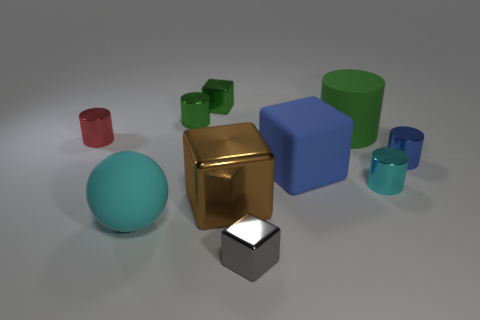Subtract all brown balls. How many green cylinders are left? 2 Subtract all gray metal cubes. How many cubes are left? 3 Subtract all red cylinders. How many cylinders are left? 4 Subtract 1 blocks. How many blocks are left? 3 Add 7 tiny red metallic balls. How many tiny red metallic balls exist? 7 Subtract 0 purple balls. How many objects are left? 10 Subtract all balls. How many objects are left? 9 Subtract all gray cylinders. Subtract all yellow spheres. How many cylinders are left? 5 Subtract all gray things. Subtract all large cyan rubber things. How many objects are left? 8 Add 9 tiny cyan metallic cylinders. How many tiny cyan metallic cylinders are left? 10 